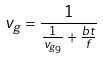Convert formula to latex. <formula><loc_0><loc_0><loc_500><loc_500>v _ { g } = \frac { 1 } { \frac { 1 } { v _ { g _ { 9 } } } + \frac { b t } { f } }</formula> 